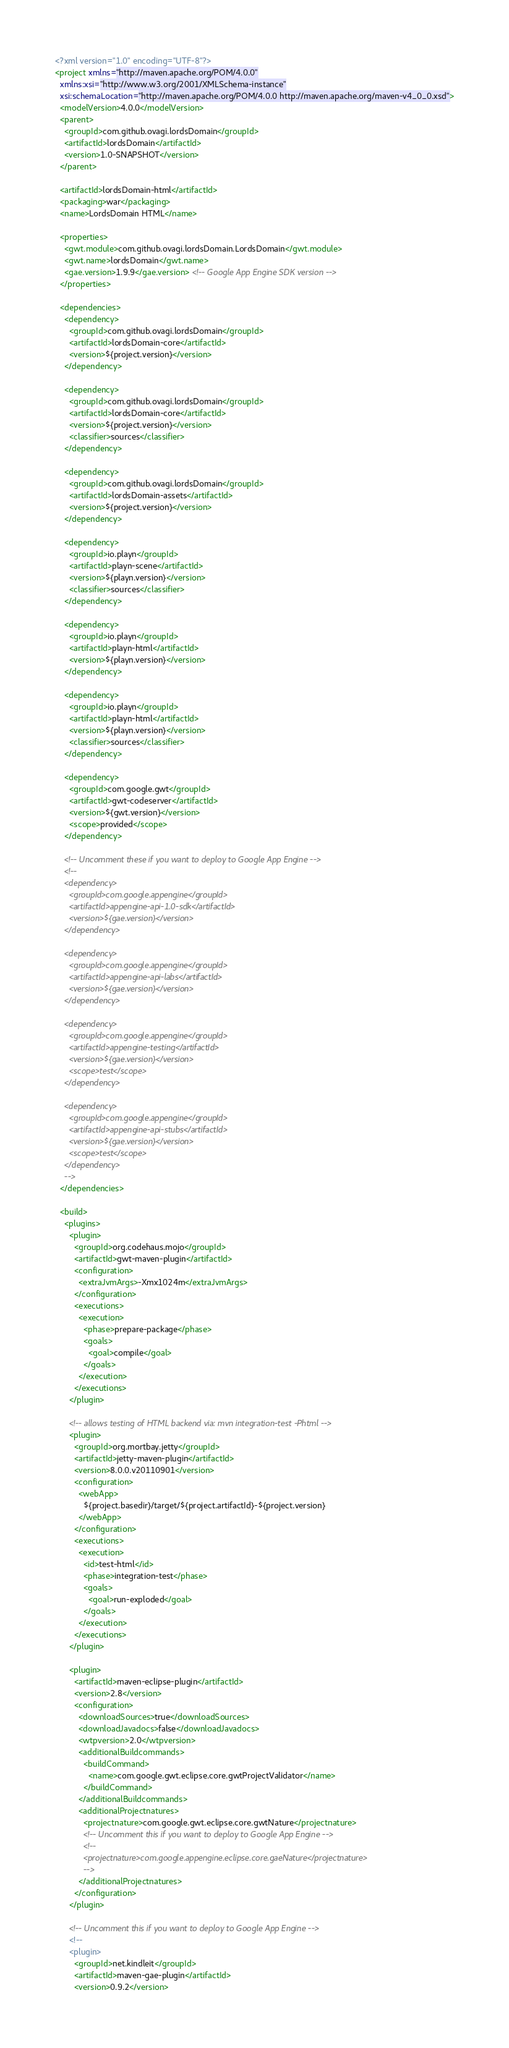Convert code to text. <code><loc_0><loc_0><loc_500><loc_500><_XML_><?xml version="1.0" encoding="UTF-8"?>
<project xmlns="http://maven.apache.org/POM/4.0.0"
  xmlns:xsi="http://www.w3.org/2001/XMLSchema-instance"
  xsi:schemaLocation="http://maven.apache.org/POM/4.0.0 http://maven.apache.org/maven-v4_0_0.xsd">
  <modelVersion>4.0.0</modelVersion>
  <parent>
    <groupId>com.github.ovagi.lordsDomain</groupId>
    <artifactId>lordsDomain</artifactId>
    <version>1.0-SNAPSHOT</version>
  </parent>

  <artifactId>lordsDomain-html</artifactId>
  <packaging>war</packaging>
  <name>LordsDomain HTML</name>

  <properties>
    <gwt.module>com.github.ovagi.lordsDomain.LordsDomain</gwt.module>
    <gwt.name>lordsDomain</gwt.name>
    <gae.version>1.9.9</gae.version> <!-- Google App Engine SDK version -->
  </properties>

  <dependencies>
    <dependency>
      <groupId>com.github.ovagi.lordsDomain</groupId>
      <artifactId>lordsDomain-core</artifactId>
      <version>${project.version}</version>
    </dependency>

    <dependency>
      <groupId>com.github.ovagi.lordsDomain</groupId>
      <artifactId>lordsDomain-core</artifactId>
      <version>${project.version}</version>
      <classifier>sources</classifier>
    </dependency>

    <dependency>
      <groupId>com.github.ovagi.lordsDomain</groupId>
      <artifactId>lordsDomain-assets</artifactId>
      <version>${project.version}</version>
    </dependency>

    <dependency>
      <groupId>io.playn</groupId>
      <artifactId>playn-scene</artifactId>
      <version>${playn.version}</version>
      <classifier>sources</classifier>
    </dependency>

    <dependency>
      <groupId>io.playn</groupId>
      <artifactId>playn-html</artifactId>
      <version>${playn.version}</version>
    </dependency>

    <dependency>
      <groupId>io.playn</groupId>
      <artifactId>playn-html</artifactId>
      <version>${playn.version}</version>
      <classifier>sources</classifier>
    </dependency>

    <dependency>
      <groupId>com.google.gwt</groupId>
      <artifactId>gwt-codeserver</artifactId>
      <version>${gwt.version}</version>
      <scope>provided</scope>
    </dependency>

    <!-- Uncomment these if you want to deploy to Google App Engine -->
    <!--
    <dependency>
      <groupId>com.google.appengine</groupId>
      <artifactId>appengine-api-1.0-sdk</artifactId>
      <version>${gae.version}</version>
    </dependency>

    <dependency>
      <groupId>com.google.appengine</groupId>
      <artifactId>appengine-api-labs</artifactId>
      <version>${gae.version}</version>
    </dependency>

    <dependency>
      <groupId>com.google.appengine</groupId>
      <artifactId>appengine-testing</artifactId>
      <version>${gae.version}</version>
      <scope>test</scope>
    </dependency>

    <dependency>
      <groupId>com.google.appengine</groupId>
      <artifactId>appengine-api-stubs</artifactId>
      <version>${gae.version}</version>
      <scope>test</scope>
    </dependency>
    -->
  </dependencies>

  <build>
    <plugins>
      <plugin>
        <groupId>org.codehaus.mojo</groupId>
        <artifactId>gwt-maven-plugin</artifactId>
        <configuration>
          <extraJvmArgs>-Xmx1024m</extraJvmArgs>
        </configuration>
        <executions>
          <execution>
            <phase>prepare-package</phase>
            <goals>
              <goal>compile</goal>
            </goals>
          </execution>
        </executions>
      </plugin>

      <!-- allows testing of HTML backend via: mvn integration-test -Phtml -->
      <plugin>
        <groupId>org.mortbay.jetty</groupId>
        <artifactId>jetty-maven-plugin</artifactId>
        <version>8.0.0.v20110901</version>
        <configuration>
          <webApp>
            ${project.basedir}/target/${project.artifactId}-${project.version}
          </webApp>
        </configuration>
        <executions>
          <execution>
            <id>test-html</id>
            <phase>integration-test</phase>
            <goals>
              <goal>run-exploded</goal>
            </goals>
          </execution>
        </executions>
      </plugin>

      <plugin>
        <artifactId>maven-eclipse-plugin</artifactId>
        <version>2.8</version>
        <configuration>
          <downloadSources>true</downloadSources>
          <downloadJavadocs>false</downloadJavadocs>
          <wtpversion>2.0</wtpversion>
          <additionalBuildcommands>
            <buildCommand>
              <name>com.google.gwt.eclipse.core.gwtProjectValidator</name>
            </buildCommand>
          </additionalBuildcommands>
          <additionalProjectnatures>
            <projectnature>com.google.gwt.eclipse.core.gwtNature</projectnature>
            <!-- Uncomment this if you want to deploy to Google App Engine -->
            <!--
            <projectnature>com.google.appengine.eclipse.core.gaeNature</projectnature>
            -->
          </additionalProjectnatures>
        </configuration>
      </plugin>

      <!-- Uncomment this if you want to deploy to Google App Engine -->
      <!--
      <plugin>
        <groupId>net.kindleit</groupId>
        <artifactId>maven-gae-plugin</artifactId>
        <version>0.9.2</version></code> 